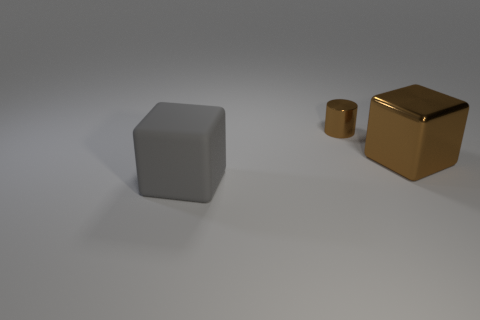How many other things are there of the same color as the small shiny cylinder?
Offer a terse response. 1. There is a thing that is the same color as the metallic cylinder; what size is it?
Your response must be concise. Large. Does the brown cube have the same size as the cylinder?
Offer a very short reply. No. What is the material of the large block that is to the left of the metal cylinder?
Offer a terse response. Rubber. How many other things are there of the same shape as the large brown shiny object?
Your response must be concise. 1. Is the shape of the large metallic thing the same as the matte thing?
Offer a terse response. Yes. There is a tiny metallic object; are there any brown cylinders on the right side of it?
Keep it short and to the point. No. How many objects are either small gray matte blocks or big gray things?
Ensure brevity in your answer.  1. What number of other things are the same size as the brown cylinder?
Make the answer very short. 0. What number of objects are both in front of the small metallic thing and right of the big gray rubber block?
Your answer should be compact. 1. 